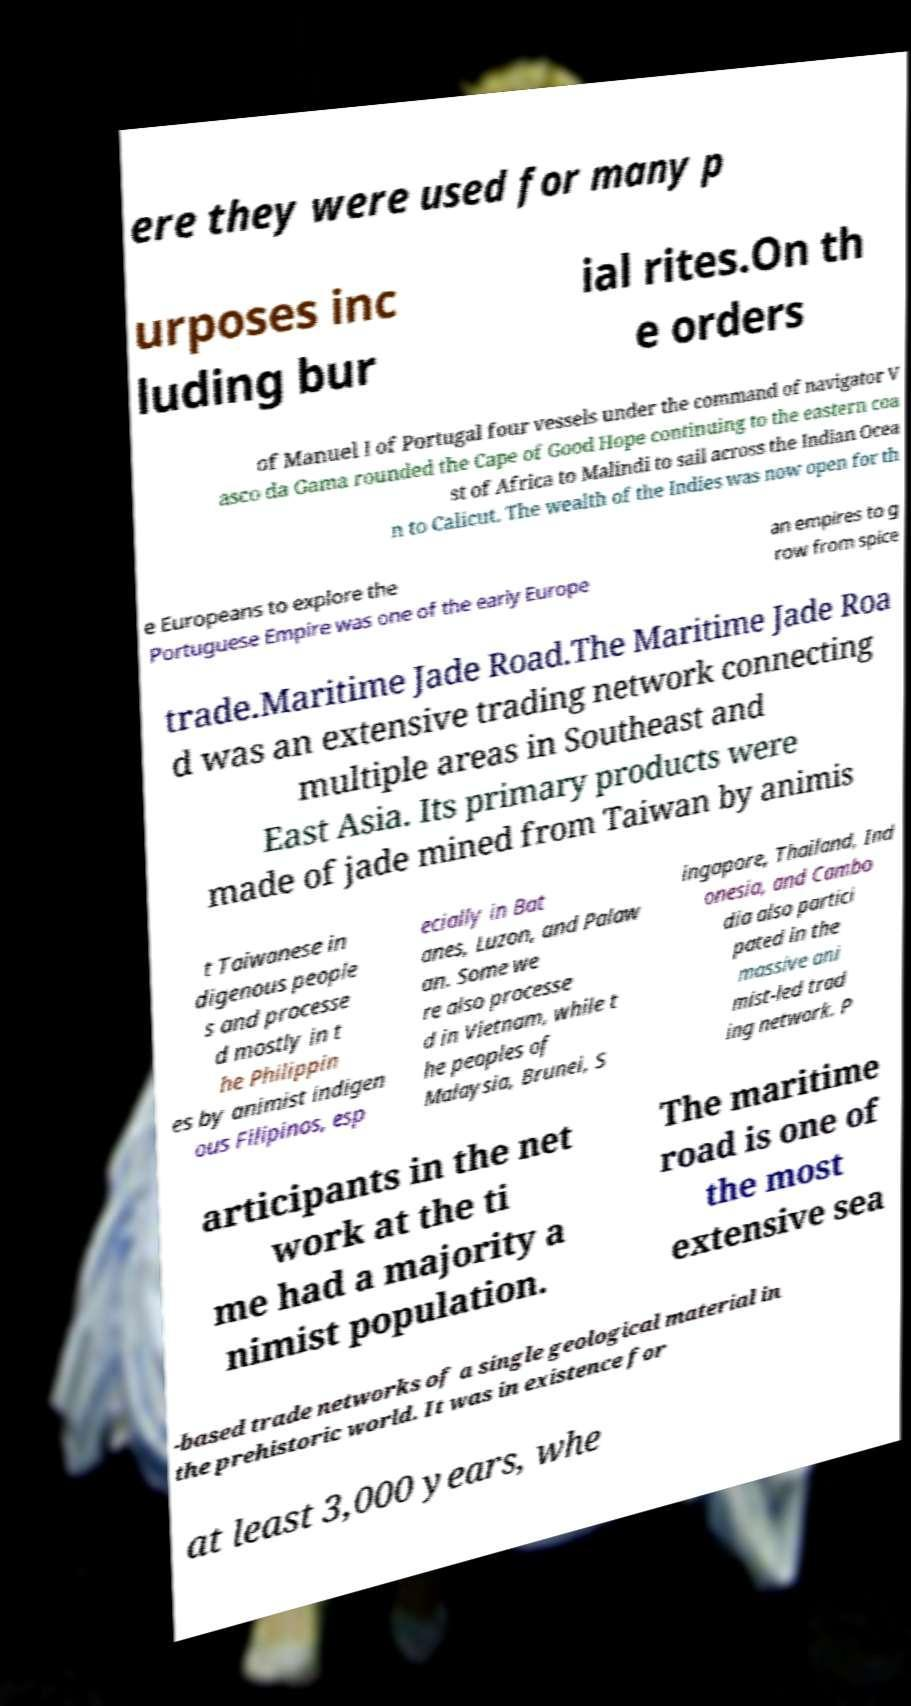Can you read and provide the text displayed in the image?This photo seems to have some interesting text. Can you extract and type it out for me? ere they were used for many p urposes inc luding bur ial rites.On th e orders of Manuel I of Portugal four vessels under the command of navigator V asco da Gama rounded the Cape of Good Hope continuing to the eastern coa st of Africa to Malindi to sail across the Indian Ocea n to Calicut. The wealth of the Indies was now open for th e Europeans to explore the Portuguese Empire was one of the early Europe an empires to g row from spice trade.Maritime Jade Road.The Maritime Jade Roa d was an extensive trading network connecting multiple areas in Southeast and East Asia. Its primary products were made of jade mined from Taiwan by animis t Taiwanese in digenous people s and processe d mostly in t he Philippin es by animist indigen ous Filipinos, esp ecially in Bat anes, Luzon, and Palaw an. Some we re also processe d in Vietnam, while t he peoples of Malaysia, Brunei, S ingapore, Thailand, Ind onesia, and Cambo dia also partici pated in the massive ani mist-led trad ing network. P articipants in the net work at the ti me had a majority a nimist population. The maritime road is one of the most extensive sea -based trade networks of a single geological material in the prehistoric world. It was in existence for at least 3,000 years, whe 